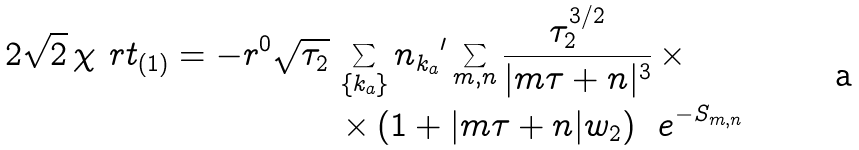Convert formula to latex. <formula><loc_0><loc_0><loc_500><loc_500>2 \sqrt { 2 } \, \chi ^ { \ } r t _ { ( 1 ) } = - r ^ { 0 } \sqrt { \tau _ { 2 } } \, & \sum _ { \{ k _ { a } \} } n _ { k _ { a } } { ^ { \prime } } \sum _ { m , n } \frac { \tau _ { 2 } ^ { 3 / 2 } } { | m \tau + n | ^ { 3 } } \, \times \\ & \times \left ( 1 + | m \tau + n | w _ { 2 } \right ) \, \ e ^ { - S _ { m , n } }</formula> 